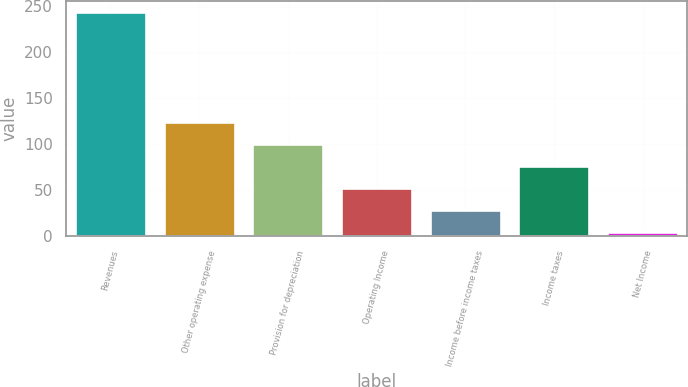<chart> <loc_0><loc_0><loc_500><loc_500><bar_chart><fcel>Revenues<fcel>Other operating expense<fcel>Provision for depreciation<fcel>Operating Income<fcel>Income before income taxes<fcel>Income taxes<fcel>Net Income<nl><fcel>243.2<fcel>124.2<fcel>100.4<fcel>52.8<fcel>29<fcel>76.6<fcel>5.2<nl></chart> 